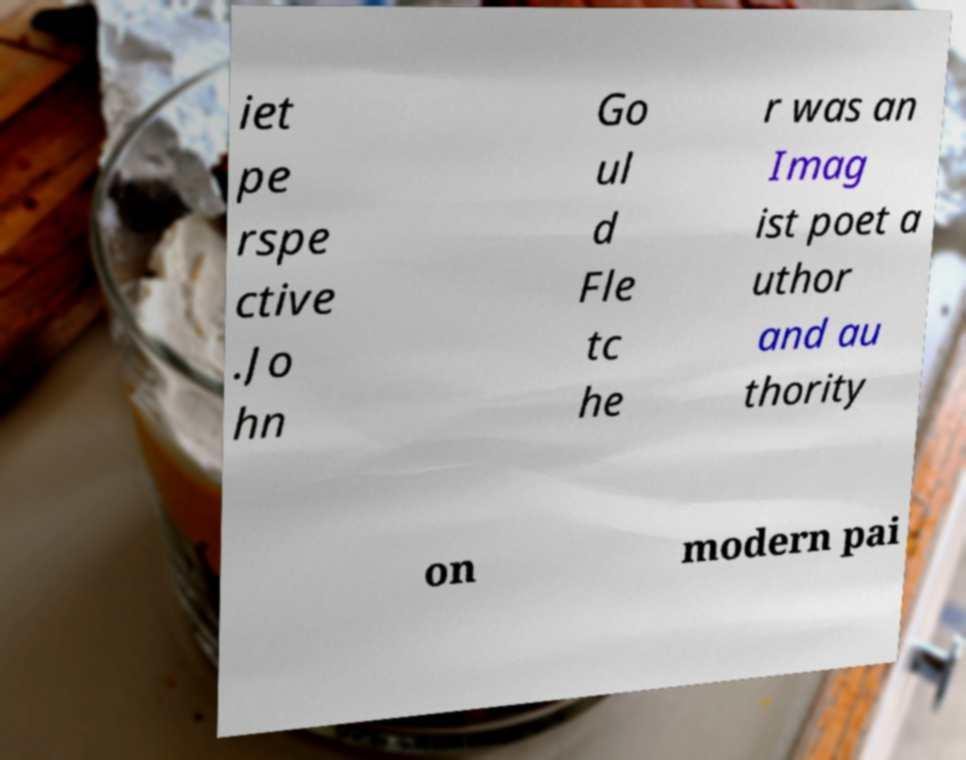For documentation purposes, I need the text within this image transcribed. Could you provide that? iet pe rspe ctive .Jo hn Go ul d Fle tc he r was an Imag ist poet a uthor and au thority on modern pai 